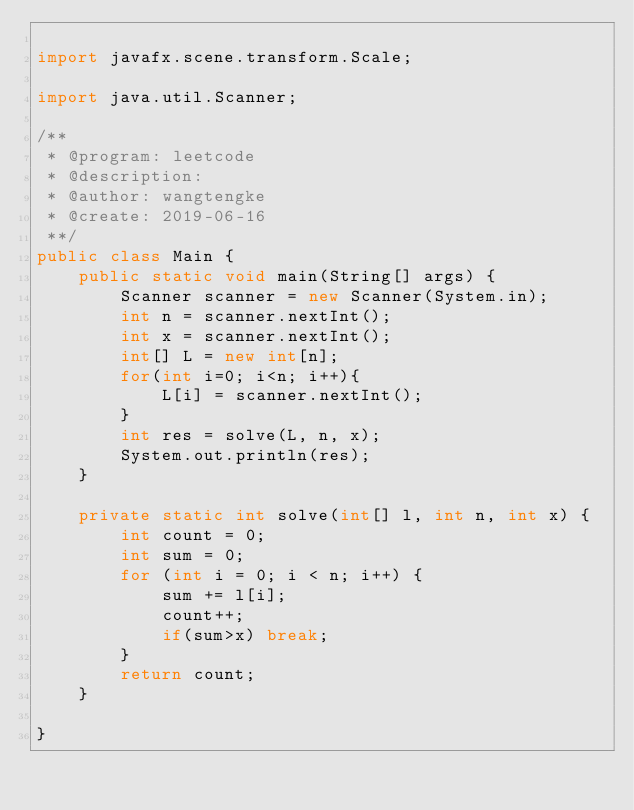Convert code to text. <code><loc_0><loc_0><loc_500><loc_500><_Java_>
import javafx.scene.transform.Scale;

import java.util.Scanner;

/**
 * @program: leetcode
 * @description:
 * @author: wangtengke
 * @create: 2019-06-16
 **/
public class Main {
    public static void main(String[] args) {
        Scanner scanner = new Scanner(System.in);
        int n = scanner.nextInt();
        int x = scanner.nextInt();
        int[] L = new int[n];
        for(int i=0; i<n; i++){
            L[i] = scanner.nextInt();
        }
        int res = solve(L, n, x);
        System.out.println(res);
    }

    private static int solve(int[] l, int n, int x) {
        int count = 0;
        int sum = 0;
        for (int i = 0; i < n; i++) {
            sum += l[i];
            count++;
            if(sum>x) break;
        }
        return count;
    }

}
</code> 